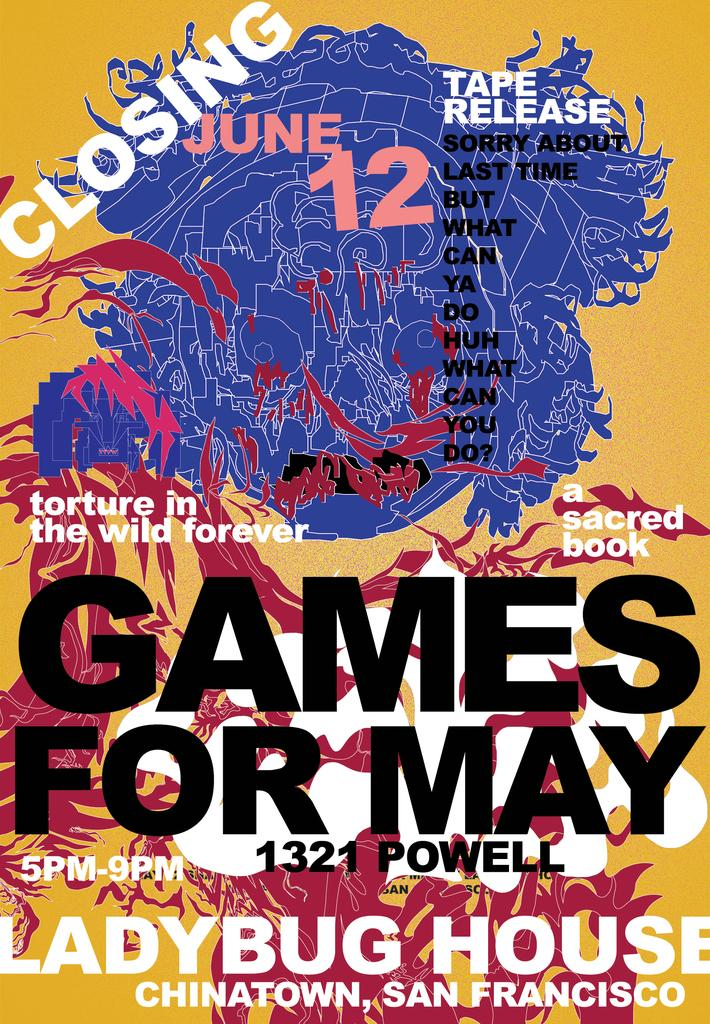Provide a one-sentence caption for the provided image. Poster for Games for May that takes place on Powell street. 